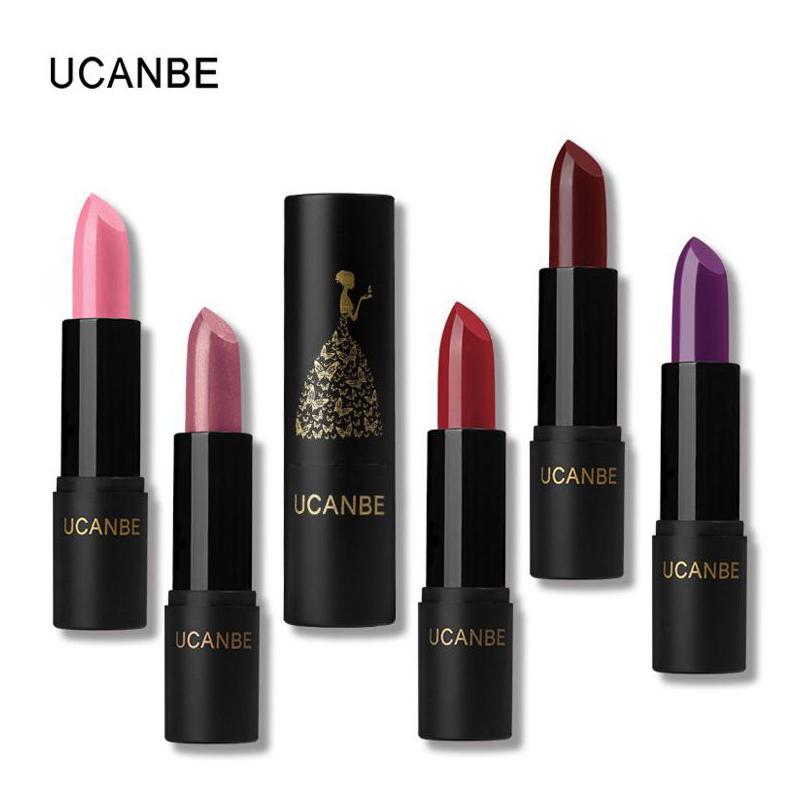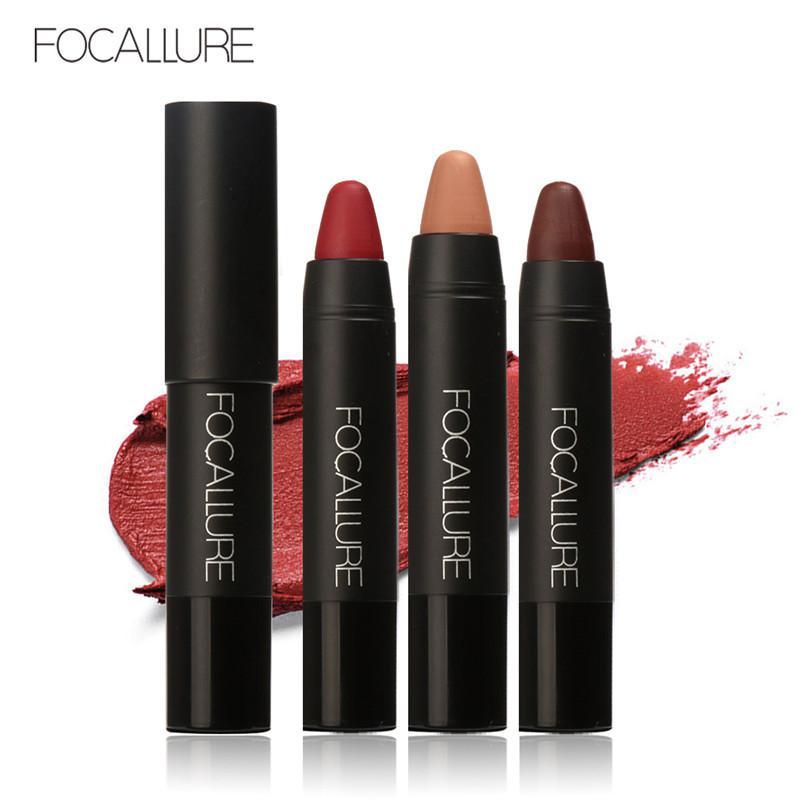The first image is the image on the left, the second image is the image on the right. Examine the images to the left and right. Is the description "There is a square container of makeup." accurate? Answer yes or no. No. The first image is the image on the left, the second image is the image on the right. For the images displayed, is the sentence "An image shows a row of three items, including a narrow box." factually correct? Answer yes or no. No. 